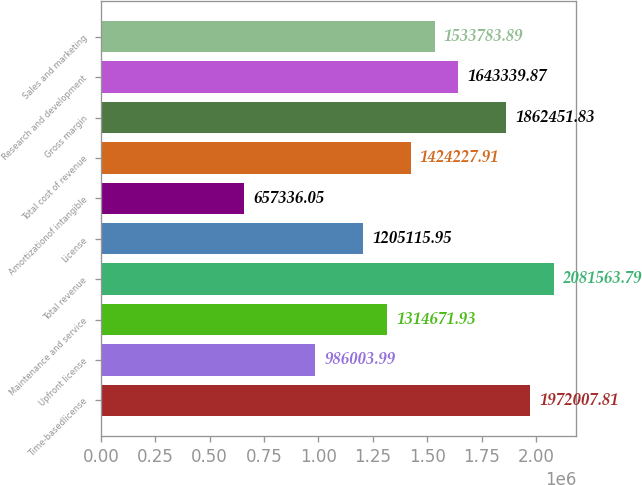<chart> <loc_0><loc_0><loc_500><loc_500><bar_chart><fcel>Time-basedlicense<fcel>Upfront license<fcel>Maintenance and service<fcel>Total revenue<fcel>License<fcel>Amortizationof intangible<fcel>Total cost of revenue<fcel>Gross margin<fcel>Research and development<fcel>Sales and marketing<nl><fcel>1.97201e+06<fcel>986004<fcel>1.31467e+06<fcel>2.08156e+06<fcel>1.20512e+06<fcel>657336<fcel>1.42423e+06<fcel>1.86245e+06<fcel>1.64334e+06<fcel>1.53378e+06<nl></chart> 